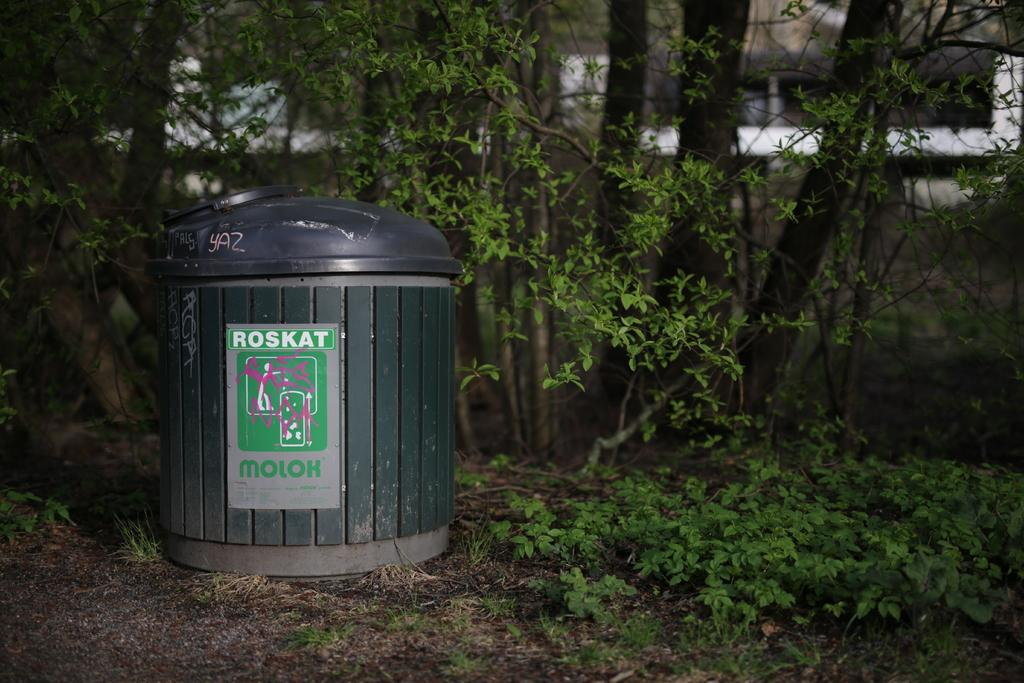<image>
Render a clear and concise summary of the photo. A green garbage can outdoors with a Roskat label on the front. 